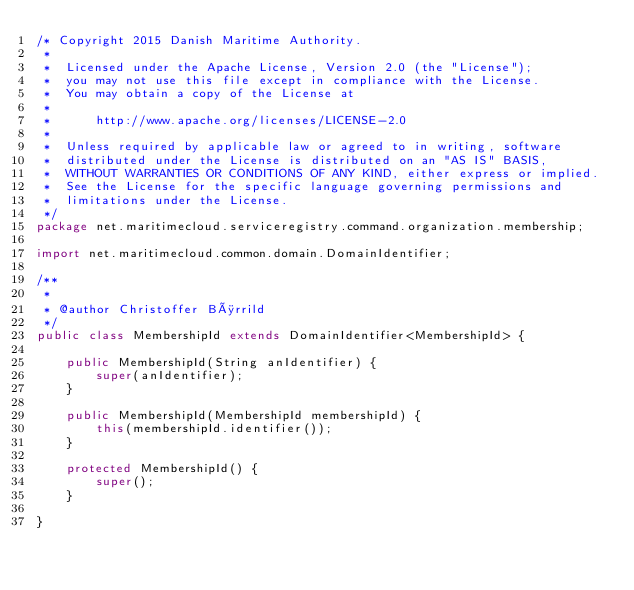<code> <loc_0><loc_0><loc_500><loc_500><_Java_>/* Copyright 2015 Danish Maritime Authority.
 *
 *  Licensed under the Apache License, Version 2.0 (the "License");
 *  you may not use this file except in compliance with the License.
 *  You may obtain a copy of the License at
 *
 *      http://www.apache.org/licenses/LICENSE-2.0
 *
 *  Unless required by applicable law or agreed to in writing, software
 *  distributed under the License is distributed on an "AS IS" BASIS,
 *  WITHOUT WARRANTIES OR CONDITIONS OF ANY KIND, either express or implied.
 *  See the License for the specific language governing permissions and
 *  limitations under the License.
 */
package net.maritimecloud.serviceregistry.command.organization.membership;

import net.maritimecloud.common.domain.DomainIdentifier;

/**
 *
 * @author Christoffer Børrild
 */
public class MembershipId extends DomainIdentifier<MembershipId> {

    public MembershipId(String anIdentifier) {
        super(anIdentifier);
    }

    public MembershipId(MembershipId membershipId) {
        this(membershipId.identifier());
    }

    protected MembershipId() {
        super();
    }

}
</code> 